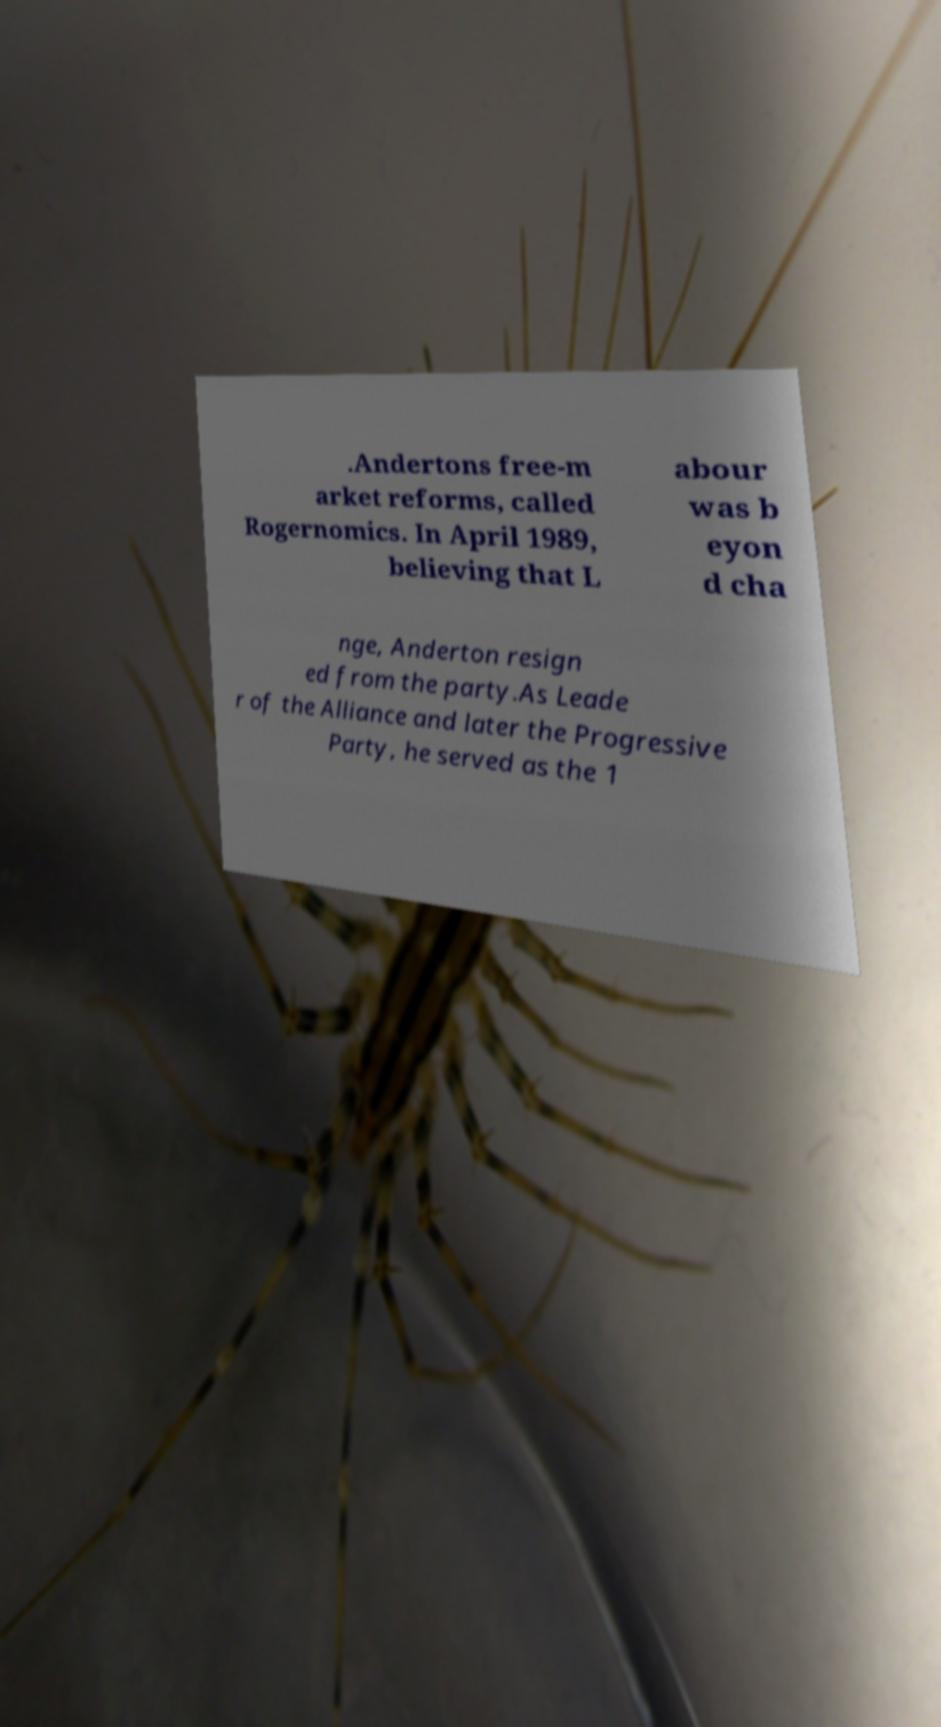Could you extract and type out the text from this image? .Andertons free-m arket reforms, called Rogernomics. In April 1989, believing that L abour was b eyon d cha nge, Anderton resign ed from the party.As Leade r of the Alliance and later the Progressive Party, he served as the 1 